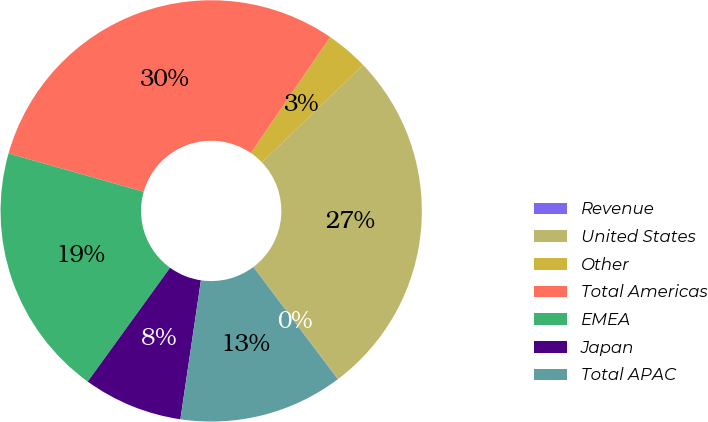Convert chart to OTSL. <chart><loc_0><loc_0><loc_500><loc_500><pie_chart><fcel>Revenue<fcel>United States<fcel>Other<fcel>Total Americas<fcel>EMEA<fcel>Japan<fcel>Total APAC<nl><fcel>0.03%<fcel>26.89%<fcel>3.27%<fcel>30.16%<fcel>19.43%<fcel>7.63%<fcel>12.6%<nl></chart> 